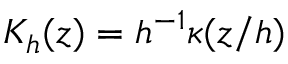Convert formula to latex. <formula><loc_0><loc_0><loc_500><loc_500>K _ { h } ( z ) = h ^ { - 1 } \kappa ( z / h )</formula> 